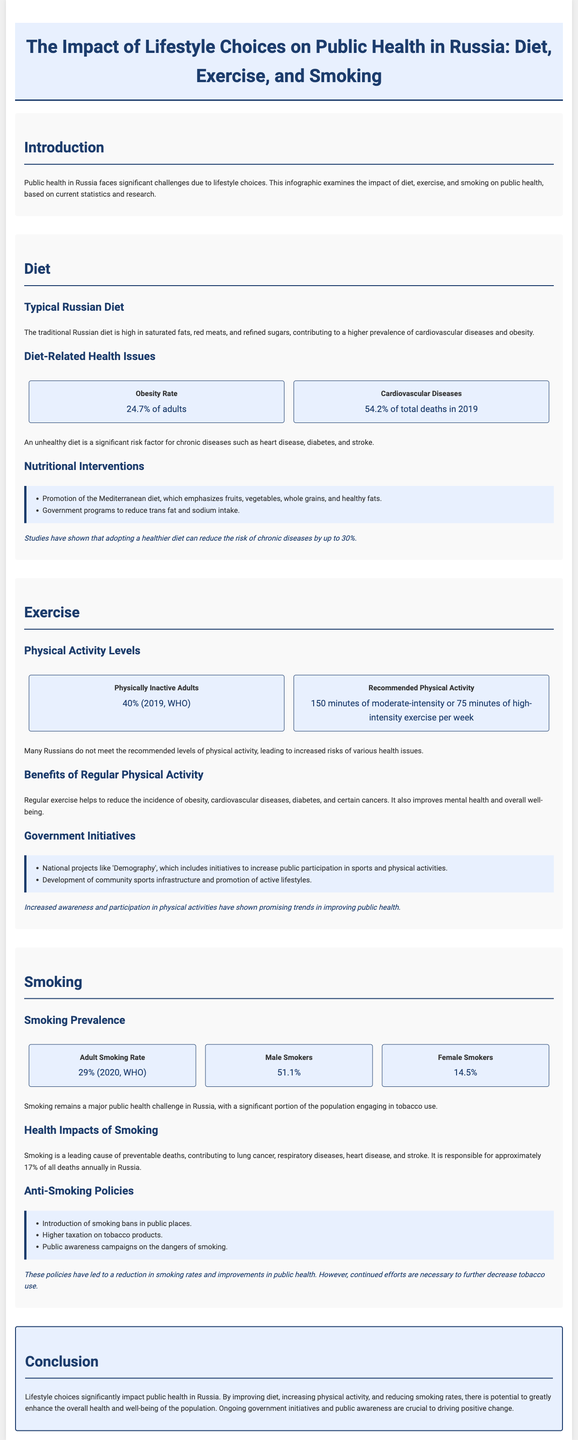what percentage of adults are obese in Russia? The document states that 24.7% of adults are obese, highlighting a significant health issue.
Answer: 24.7% what is the adult smoking rate in Russia? According to the document, the adult smoking rate is stated as 29% as of 2020.
Answer: 29% what contributes to 54.2% of total deaths in Russia according to the infographic? The document mentions that cardiovascular diseases account for 54.2% of total deaths in 2019.
Answer: cardiovascular diseases how many physically inactive adults are there in Russia? The document indicates that 40% of adults were physically inactive in 2019.
Answer: 40% what are the recommended weekly physical activity levels? The document specifies the recommended physical activity as 150 minutes of moderate or 75 minutes of high-intensity exercise per week.
Answer: 150 minutes which dietary intervention promotes fruits, vegetables, whole grains, and healthy fats? The infographic lists the Mediterranean diet as a nutritional intervention promoting these healthy eating choices.
Answer: Mediterranean diet what percentage of male smokers were reported in the document? The document states that 51.1% of adult smokers in Russia are male.
Answer: 51.1% what is a major health consequence of smoking mentioned in the document? The infographic identifies lung cancer as a major health consequence of smoking.
Answer: lung cancer what government program aims to promote public participation in sports and physical activities? The document details the national project 'Demography' as focusing on increasing public participation in sports.
Answer: Demography 